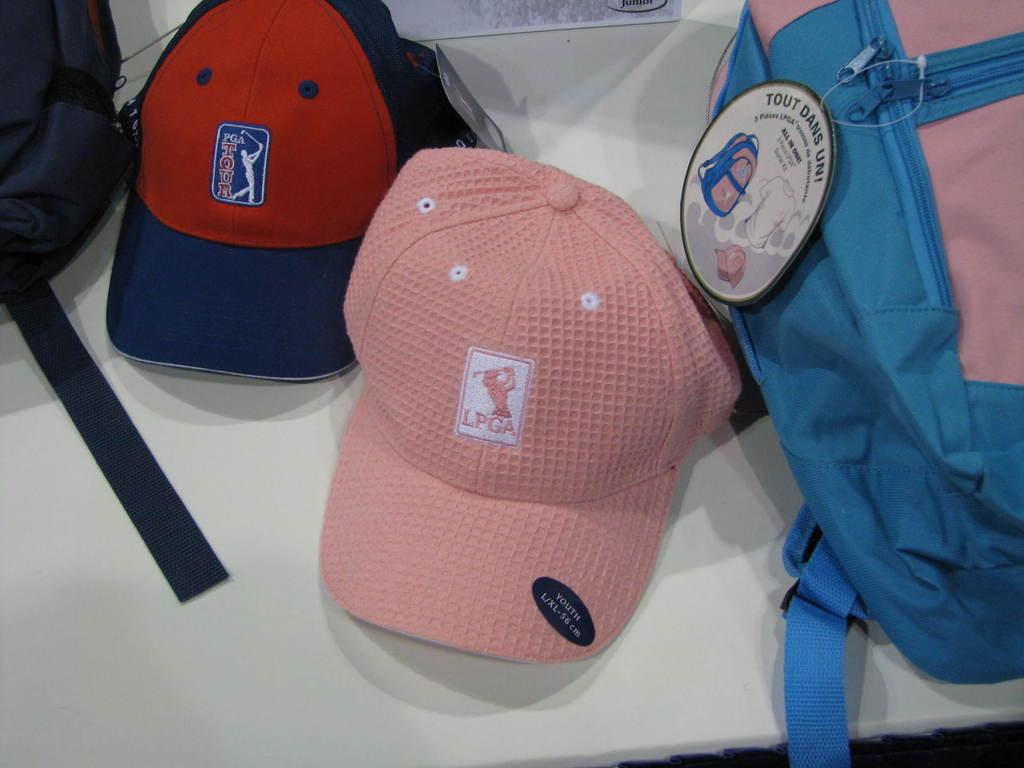<image>
Summarize the visual content of the image. A L/XL youth sized LPGA hat along with some other items. 